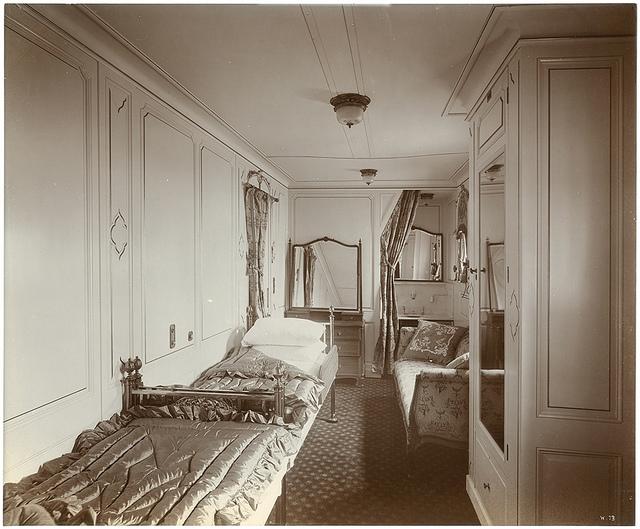What type of room is this?
Short answer required. Bedroom. How many beds are in this room?
Give a very brief answer. 3. What color is the photo?
Write a very short answer. Black and white. 